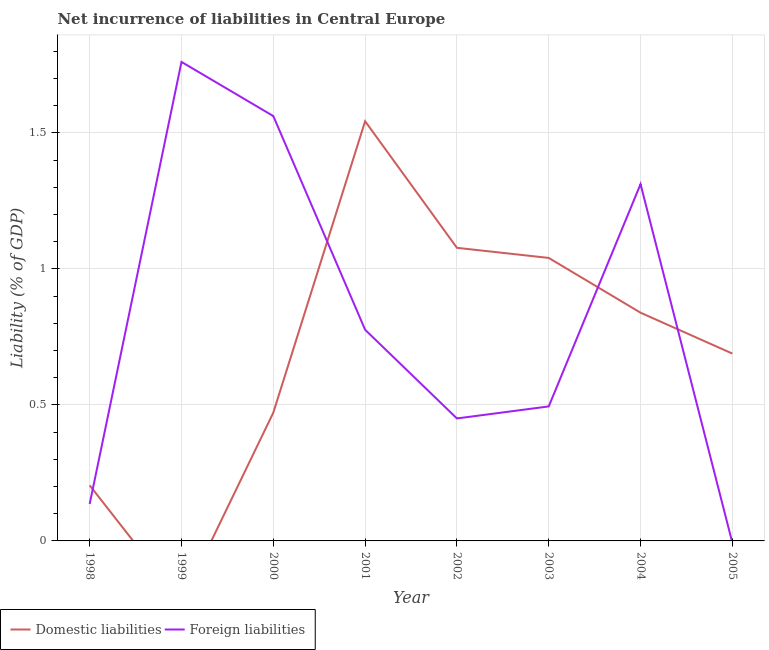What is the incurrence of domestic liabilities in 2005?
Provide a succinct answer. 0.69. Across all years, what is the maximum incurrence of domestic liabilities?
Offer a terse response. 1.54. Across all years, what is the minimum incurrence of domestic liabilities?
Ensure brevity in your answer.  0. In which year was the incurrence of foreign liabilities maximum?
Your answer should be very brief. 1999. What is the total incurrence of foreign liabilities in the graph?
Offer a terse response. 6.49. What is the difference between the incurrence of foreign liabilities in 1999 and that in 2000?
Make the answer very short. 0.2. What is the difference between the incurrence of domestic liabilities in 2005 and the incurrence of foreign liabilities in 1999?
Offer a very short reply. -1.07. What is the average incurrence of domestic liabilities per year?
Offer a very short reply. 0.73. In the year 2003, what is the difference between the incurrence of foreign liabilities and incurrence of domestic liabilities?
Keep it short and to the point. -0.55. In how many years, is the incurrence of foreign liabilities greater than 1.4 %?
Provide a succinct answer. 2. What is the ratio of the incurrence of foreign liabilities in 2002 to that in 2003?
Make the answer very short. 0.91. Is the difference between the incurrence of domestic liabilities in 2000 and 2003 greater than the difference between the incurrence of foreign liabilities in 2000 and 2003?
Give a very brief answer. No. What is the difference between the highest and the second highest incurrence of domestic liabilities?
Your response must be concise. 0.47. What is the difference between the highest and the lowest incurrence of domestic liabilities?
Provide a short and direct response. 1.54. Does the incurrence of foreign liabilities monotonically increase over the years?
Offer a terse response. No. Is the incurrence of foreign liabilities strictly less than the incurrence of domestic liabilities over the years?
Your response must be concise. No. How many lines are there?
Keep it short and to the point. 2. How many years are there in the graph?
Offer a very short reply. 8. Does the graph contain grids?
Offer a terse response. Yes. How many legend labels are there?
Keep it short and to the point. 2. How are the legend labels stacked?
Make the answer very short. Horizontal. What is the title of the graph?
Your response must be concise. Net incurrence of liabilities in Central Europe. What is the label or title of the X-axis?
Ensure brevity in your answer.  Year. What is the label or title of the Y-axis?
Provide a short and direct response. Liability (% of GDP). What is the Liability (% of GDP) in Domestic liabilities in 1998?
Give a very brief answer. 0.2. What is the Liability (% of GDP) in Foreign liabilities in 1998?
Your answer should be very brief. 0.14. What is the Liability (% of GDP) of Domestic liabilities in 1999?
Make the answer very short. 0. What is the Liability (% of GDP) in Foreign liabilities in 1999?
Your answer should be compact. 1.76. What is the Liability (% of GDP) in Domestic liabilities in 2000?
Your answer should be compact. 0.47. What is the Liability (% of GDP) of Foreign liabilities in 2000?
Provide a succinct answer. 1.56. What is the Liability (% of GDP) of Domestic liabilities in 2001?
Offer a terse response. 1.54. What is the Liability (% of GDP) in Foreign liabilities in 2001?
Give a very brief answer. 0.78. What is the Liability (% of GDP) of Domestic liabilities in 2002?
Your answer should be very brief. 1.08. What is the Liability (% of GDP) in Foreign liabilities in 2002?
Your answer should be compact. 0.45. What is the Liability (% of GDP) in Domestic liabilities in 2003?
Keep it short and to the point. 1.04. What is the Liability (% of GDP) of Foreign liabilities in 2003?
Make the answer very short. 0.49. What is the Liability (% of GDP) of Domestic liabilities in 2004?
Your response must be concise. 0.84. What is the Liability (% of GDP) of Foreign liabilities in 2004?
Offer a very short reply. 1.31. What is the Liability (% of GDP) of Domestic liabilities in 2005?
Give a very brief answer. 0.69. What is the Liability (% of GDP) in Foreign liabilities in 2005?
Your response must be concise. 0. Across all years, what is the maximum Liability (% of GDP) in Domestic liabilities?
Your answer should be compact. 1.54. Across all years, what is the maximum Liability (% of GDP) in Foreign liabilities?
Your response must be concise. 1.76. Across all years, what is the minimum Liability (% of GDP) of Domestic liabilities?
Provide a succinct answer. 0. What is the total Liability (% of GDP) of Domestic liabilities in the graph?
Give a very brief answer. 5.86. What is the total Liability (% of GDP) in Foreign liabilities in the graph?
Provide a succinct answer. 6.49. What is the difference between the Liability (% of GDP) in Foreign liabilities in 1998 and that in 1999?
Offer a very short reply. -1.62. What is the difference between the Liability (% of GDP) of Domestic liabilities in 1998 and that in 2000?
Make the answer very short. -0.27. What is the difference between the Liability (% of GDP) of Foreign liabilities in 1998 and that in 2000?
Your answer should be very brief. -1.43. What is the difference between the Liability (% of GDP) in Domestic liabilities in 1998 and that in 2001?
Make the answer very short. -1.34. What is the difference between the Liability (% of GDP) of Foreign liabilities in 1998 and that in 2001?
Make the answer very short. -0.64. What is the difference between the Liability (% of GDP) of Domestic liabilities in 1998 and that in 2002?
Make the answer very short. -0.87. What is the difference between the Liability (% of GDP) of Foreign liabilities in 1998 and that in 2002?
Provide a succinct answer. -0.31. What is the difference between the Liability (% of GDP) of Domestic liabilities in 1998 and that in 2003?
Ensure brevity in your answer.  -0.84. What is the difference between the Liability (% of GDP) of Foreign liabilities in 1998 and that in 2003?
Offer a very short reply. -0.36. What is the difference between the Liability (% of GDP) of Domestic liabilities in 1998 and that in 2004?
Your response must be concise. -0.63. What is the difference between the Liability (% of GDP) of Foreign liabilities in 1998 and that in 2004?
Give a very brief answer. -1.18. What is the difference between the Liability (% of GDP) in Domestic liabilities in 1998 and that in 2005?
Ensure brevity in your answer.  -0.48. What is the difference between the Liability (% of GDP) of Foreign liabilities in 1999 and that in 2000?
Provide a short and direct response. 0.2. What is the difference between the Liability (% of GDP) in Foreign liabilities in 1999 and that in 2001?
Provide a succinct answer. 0.98. What is the difference between the Liability (% of GDP) in Foreign liabilities in 1999 and that in 2002?
Provide a short and direct response. 1.31. What is the difference between the Liability (% of GDP) in Foreign liabilities in 1999 and that in 2003?
Offer a very short reply. 1.27. What is the difference between the Liability (% of GDP) of Foreign liabilities in 1999 and that in 2004?
Your answer should be compact. 0.45. What is the difference between the Liability (% of GDP) in Domestic liabilities in 2000 and that in 2001?
Make the answer very short. -1.07. What is the difference between the Liability (% of GDP) in Foreign liabilities in 2000 and that in 2001?
Your answer should be very brief. 0.79. What is the difference between the Liability (% of GDP) in Domestic liabilities in 2000 and that in 2002?
Your answer should be very brief. -0.61. What is the difference between the Liability (% of GDP) in Foreign liabilities in 2000 and that in 2002?
Offer a very short reply. 1.11. What is the difference between the Liability (% of GDP) of Domestic liabilities in 2000 and that in 2003?
Your answer should be very brief. -0.57. What is the difference between the Liability (% of GDP) in Foreign liabilities in 2000 and that in 2003?
Offer a terse response. 1.07. What is the difference between the Liability (% of GDP) in Domestic liabilities in 2000 and that in 2004?
Ensure brevity in your answer.  -0.37. What is the difference between the Liability (% of GDP) of Foreign liabilities in 2000 and that in 2004?
Your answer should be compact. 0.25. What is the difference between the Liability (% of GDP) of Domestic liabilities in 2000 and that in 2005?
Make the answer very short. -0.22. What is the difference between the Liability (% of GDP) of Domestic liabilities in 2001 and that in 2002?
Your response must be concise. 0.47. What is the difference between the Liability (% of GDP) in Foreign liabilities in 2001 and that in 2002?
Provide a short and direct response. 0.33. What is the difference between the Liability (% of GDP) in Domestic liabilities in 2001 and that in 2003?
Provide a succinct answer. 0.5. What is the difference between the Liability (% of GDP) in Foreign liabilities in 2001 and that in 2003?
Your answer should be very brief. 0.28. What is the difference between the Liability (% of GDP) in Domestic liabilities in 2001 and that in 2004?
Your answer should be compact. 0.7. What is the difference between the Liability (% of GDP) of Foreign liabilities in 2001 and that in 2004?
Offer a terse response. -0.54. What is the difference between the Liability (% of GDP) of Domestic liabilities in 2001 and that in 2005?
Make the answer very short. 0.85. What is the difference between the Liability (% of GDP) in Domestic liabilities in 2002 and that in 2003?
Provide a short and direct response. 0.04. What is the difference between the Liability (% of GDP) of Foreign liabilities in 2002 and that in 2003?
Provide a succinct answer. -0.04. What is the difference between the Liability (% of GDP) of Domestic liabilities in 2002 and that in 2004?
Keep it short and to the point. 0.24. What is the difference between the Liability (% of GDP) in Foreign liabilities in 2002 and that in 2004?
Offer a very short reply. -0.86. What is the difference between the Liability (% of GDP) in Domestic liabilities in 2002 and that in 2005?
Make the answer very short. 0.39. What is the difference between the Liability (% of GDP) in Domestic liabilities in 2003 and that in 2004?
Make the answer very short. 0.2. What is the difference between the Liability (% of GDP) in Foreign liabilities in 2003 and that in 2004?
Give a very brief answer. -0.82. What is the difference between the Liability (% of GDP) in Domestic liabilities in 2003 and that in 2005?
Offer a terse response. 0.35. What is the difference between the Liability (% of GDP) of Domestic liabilities in 2004 and that in 2005?
Ensure brevity in your answer.  0.15. What is the difference between the Liability (% of GDP) in Domestic liabilities in 1998 and the Liability (% of GDP) in Foreign liabilities in 1999?
Provide a succinct answer. -1.56. What is the difference between the Liability (% of GDP) of Domestic liabilities in 1998 and the Liability (% of GDP) of Foreign liabilities in 2000?
Your response must be concise. -1.36. What is the difference between the Liability (% of GDP) of Domestic liabilities in 1998 and the Liability (% of GDP) of Foreign liabilities in 2001?
Keep it short and to the point. -0.57. What is the difference between the Liability (% of GDP) in Domestic liabilities in 1998 and the Liability (% of GDP) in Foreign liabilities in 2002?
Your answer should be compact. -0.25. What is the difference between the Liability (% of GDP) of Domestic liabilities in 1998 and the Liability (% of GDP) of Foreign liabilities in 2003?
Your answer should be compact. -0.29. What is the difference between the Liability (% of GDP) of Domestic liabilities in 1998 and the Liability (% of GDP) of Foreign liabilities in 2004?
Give a very brief answer. -1.11. What is the difference between the Liability (% of GDP) in Domestic liabilities in 2000 and the Liability (% of GDP) in Foreign liabilities in 2001?
Provide a short and direct response. -0.3. What is the difference between the Liability (% of GDP) in Domestic liabilities in 2000 and the Liability (% of GDP) in Foreign liabilities in 2002?
Keep it short and to the point. 0.02. What is the difference between the Liability (% of GDP) in Domestic liabilities in 2000 and the Liability (% of GDP) in Foreign liabilities in 2003?
Offer a very short reply. -0.02. What is the difference between the Liability (% of GDP) in Domestic liabilities in 2000 and the Liability (% of GDP) in Foreign liabilities in 2004?
Your answer should be compact. -0.84. What is the difference between the Liability (% of GDP) in Domestic liabilities in 2001 and the Liability (% of GDP) in Foreign liabilities in 2002?
Your answer should be compact. 1.09. What is the difference between the Liability (% of GDP) in Domestic liabilities in 2001 and the Liability (% of GDP) in Foreign liabilities in 2003?
Provide a succinct answer. 1.05. What is the difference between the Liability (% of GDP) in Domestic liabilities in 2001 and the Liability (% of GDP) in Foreign liabilities in 2004?
Offer a terse response. 0.23. What is the difference between the Liability (% of GDP) of Domestic liabilities in 2002 and the Liability (% of GDP) of Foreign liabilities in 2003?
Your answer should be very brief. 0.58. What is the difference between the Liability (% of GDP) of Domestic liabilities in 2002 and the Liability (% of GDP) of Foreign liabilities in 2004?
Ensure brevity in your answer.  -0.23. What is the difference between the Liability (% of GDP) in Domestic liabilities in 2003 and the Liability (% of GDP) in Foreign liabilities in 2004?
Offer a terse response. -0.27. What is the average Liability (% of GDP) of Domestic liabilities per year?
Your response must be concise. 0.73. What is the average Liability (% of GDP) of Foreign liabilities per year?
Provide a short and direct response. 0.81. In the year 1998, what is the difference between the Liability (% of GDP) of Domestic liabilities and Liability (% of GDP) of Foreign liabilities?
Keep it short and to the point. 0.07. In the year 2000, what is the difference between the Liability (% of GDP) in Domestic liabilities and Liability (% of GDP) in Foreign liabilities?
Give a very brief answer. -1.09. In the year 2001, what is the difference between the Liability (% of GDP) in Domestic liabilities and Liability (% of GDP) in Foreign liabilities?
Your answer should be very brief. 0.77. In the year 2002, what is the difference between the Liability (% of GDP) of Domestic liabilities and Liability (% of GDP) of Foreign liabilities?
Ensure brevity in your answer.  0.63. In the year 2003, what is the difference between the Liability (% of GDP) of Domestic liabilities and Liability (% of GDP) of Foreign liabilities?
Offer a terse response. 0.55. In the year 2004, what is the difference between the Liability (% of GDP) in Domestic liabilities and Liability (% of GDP) in Foreign liabilities?
Provide a short and direct response. -0.47. What is the ratio of the Liability (% of GDP) of Foreign liabilities in 1998 to that in 1999?
Your answer should be very brief. 0.08. What is the ratio of the Liability (% of GDP) in Domestic liabilities in 1998 to that in 2000?
Offer a very short reply. 0.43. What is the ratio of the Liability (% of GDP) of Foreign liabilities in 1998 to that in 2000?
Make the answer very short. 0.09. What is the ratio of the Liability (% of GDP) of Domestic liabilities in 1998 to that in 2001?
Give a very brief answer. 0.13. What is the ratio of the Liability (% of GDP) of Foreign liabilities in 1998 to that in 2001?
Give a very brief answer. 0.17. What is the ratio of the Liability (% of GDP) in Domestic liabilities in 1998 to that in 2002?
Give a very brief answer. 0.19. What is the ratio of the Liability (% of GDP) in Foreign liabilities in 1998 to that in 2002?
Make the answer very short. 0.3. What is the ratio of the Liability (% of GDP) in Domestic liabilities in 1998 to that in 2003?
Offer a very short reply. 0.2. What is the ratio of the Liability (% of GDP) of Foreign liabilities in 1998 to that in 2003?
Your answer should be very brief. 0.27. What is the ratio of the Liability (% of GDP) in Domestic liabilities in 1998 to that in 2004?
Offer a terse response. 0.24. What is the ratio of the Liability (% of GDP) of Foreign liabilities in 1998 to that in 2004?
Your answer should be compact. 0.1. What is the ratio of the Liability (% of GDP) in Domestic liabilities in 1998 to that in 2005?
Your response must be concise. 0.3. What is the ratio of the Liability (% of GDP) in Foreign liabilities in 1999 to that in 2000?
Your answer should be very brief. 1.13. What is the ratio of the Liability (% of GDP) in Foreign liabilities in 1999 to that in 2001?
Make the answer very short. 2.27. What is the ratio of the Liability (% of GDP) of Foreign liabilities in 1999 to that in 2002?
Provide a short and direct response. 3.91. What is the ratio of the Liability (% of GDP) in Foreign liabilities in 1999 to that in 2003?
Offer a terse response. 3.56. What is the ratio of the Liability (% of GDP) in Foreign liabilities in 1999 to that in 2004?
Make the answer very short. 1.34. What is the ratio of the Liability (% of GDP) in Domestic liabilities in 2000 to that in 2001?
Your answer should be compact. 0.31. What is the ratio of the Liability (% of GDP) in Foreign liabilities in 2000 to that in 2001?
Offer a very short reply. 2.01. What is the ratio of the Liability (% of GDP) of Domestic liabilities in 2000 to that in 2002?
Offer a very short reply. 0.44. What is the ratio of the Liability (% of GDP) of Foreign liabilities in 2000 to that in 2002?
Your answer should be compact. 3.47. What is the ratio of the Liability (% of GDP) in Domestic liabilities in 2000 to that in 2003?
Offer a very short reply. 0.45. What is the ratio of the Liability (% of GDP) in Foreign liabilities in 2000 to that in 2003?
Your response must be concise. 3.16. What is the ratio of the Liability (% of GDP) in Domestic liabilities in 2000 to that in 2004?
Your response must be concise. 0.56. What is the ratio of the Liability (% of GDP) of Foreign liabilities in 2000 to that in 2004?
Give a very brief answer. 1.19. What is the ratio of the Liability (% of GDP) of Domestic liabilities in 2000 to that in 2005?
Ensure brevity in your answer.  0.68. What is the ratio of the Liability (% of GDP) of Domestic liabilities in 2001 to that in 2002?
Offer a very short reply. 1.43. What is the ratio of the Liability (% of GDP) of Foreign liabilities in 2001 to that in 2002?
Your response must be concise. 1.72. What is the ratio of the Liability (% of GDP) in Domestic liabilities in 2001 to that in 2003?
Make the answer very short. 1.48. What is the ratio of the Liability (% of GDP) in Foreign liabilities in 2001 to that in 2003?
Offer a terse response. 1.57. What is the ratio of the Liability (% of GDP) in Domestic liabilities in 2001 to that in 2004?
Give a very brief answer. 1.84. What is the ratio of the Liability (% of GDP) of Foreign liabilities in 2001 to that in 2004?
Your response must be concise. 0.59. What is the ratio of the Liability (% of GDP) in Domestic liabilities in 2001 to that in 2005?
Provide a succinct answer. 2.24. What is the ratio of the Liability (% of GDP) in Domestic liabilities in 2002 to that in 2003?
Ensure brevity in your answer.  1.04. What is the ratio of the Liability (% of GDP) of Foreign liabilities in 2002 to that in 2003?
Keep it short and to the point. 0.91. What is the ratio of the Liability (% of GDP) of Domestic liabilities in 2002 to that in 2004?
Your answer should be very brief. 1.28. What is the ratio of the Liability (% of GDP) of Foreign liabilities in 2002 to that in 2004?
Provide a succinct answer. 0.34. What is the ratio of the Liability (% of GDP) of Domestic liabilities in 2002 to that in 2005?
Your answer should be compact. 1.56. What is the ratio of the Liability (% of GDP) in Domestic liabilities in 2003 to that in 2004?
Your answer should be compact. 1.24. What is the ratio of the Liability (% of GDP) of Foreign liabilities in 2003 to that in 2004?
Your answer should be very brief. 0.38. What is the ratio of the Liability (% of GDP) of Domestic liabilities in 2003 to that in 2005?
Ensure brevity in your answer.  1.51. What is the ratio of the Liability (% of GDP) in Domestic liabilities in 2004 to that in 2005?
Provide a short and direct response. 1.22. What is the difference between the highest and the second highest Liability (% of GDP) in Domestic liabilities?
Make the answer very short. 0.47. What is the difference between the highest and the second highest Liability (% of GDP) in Foreign liabilities?
Give a very brief answer. 0.2. What is the difference between the highest and the lowest Liability (% of GDP) in Domestic liabilities?
Offer a terse response. 1.54. What is the difference between the highest and the lowest Liability (% of GDP) in Foreign liabilities?
Provide a short and direct response. 1.76. 